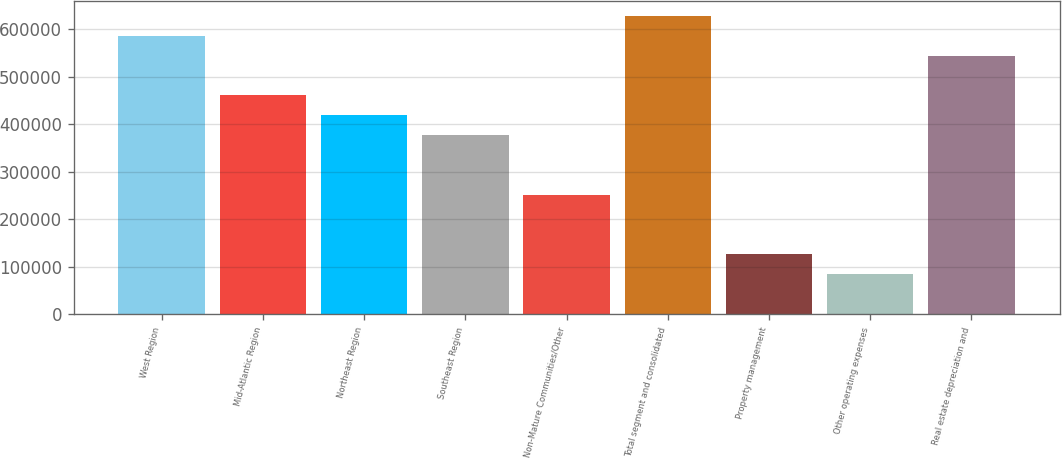<chart> <loc_0><loc_0><loc_500><loc_500><bar_chart><fcel>West Region<fcel>Mid-Atlantic Region<fcel>Northeast Region<fcel>Southeast Region<fcel>Non-Mature Communities/Other<fcel>Total segment and consolidated<fcel>Property management<fcel>Other operating expenses<fcel>Real estate depreciation and<nl><fcel>586509<fcel>461160<fcel>419377<fcel>377594<fcel>252245<fcel>628292<fcel>126897<fcel>85113.8<fcel>544726<nl></chart> 